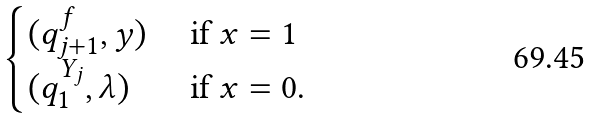<formula> <loc_0><loc_0><loc_500><loc_500>\begin{cases} ( q ^ { f } _ { j + 1 } , y ) & \text { if } x = 1 \\ ( q ^ { Y _ { j } } _ { 1 } , \lambda ) & \text { if } x = 0 . \end{cases}</formula> 